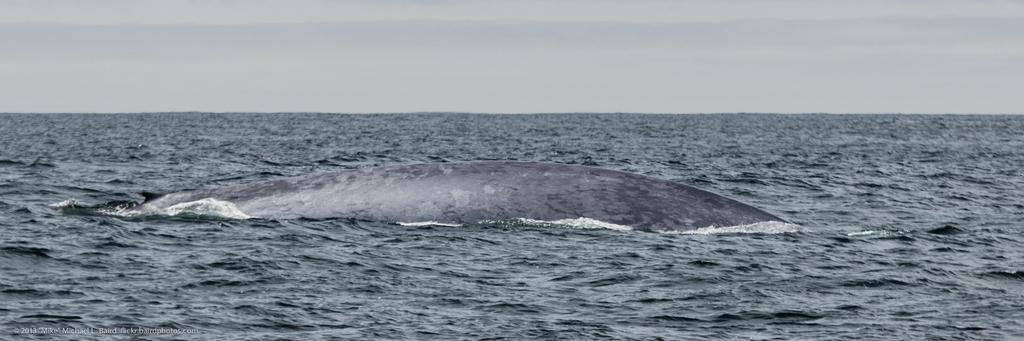Could you give a brief overview of what you see in this image? In this picture we can see a sea animal in the water and in the background we can see the sky. 